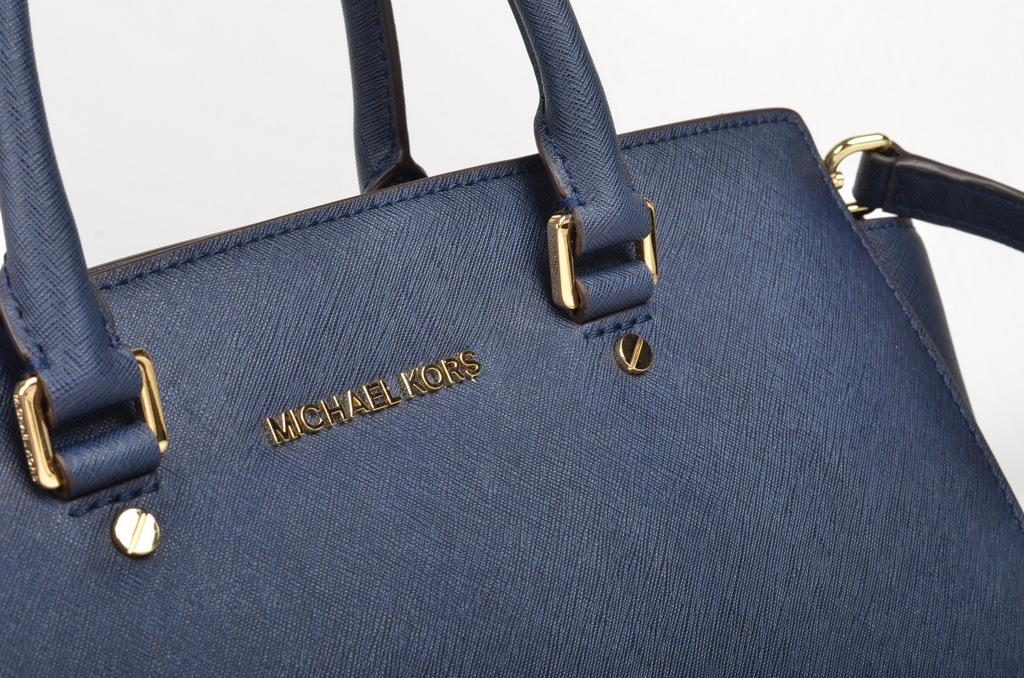What is the main object in the image? There is a handbag in the image. How many trucks are parked next to the handbag in the image? There are no trucks present in the image; it only features a handbag. Is the handbag being worn by a giant in the image? There is no giant present in the image, and the handbag is not being worn by anyone. 